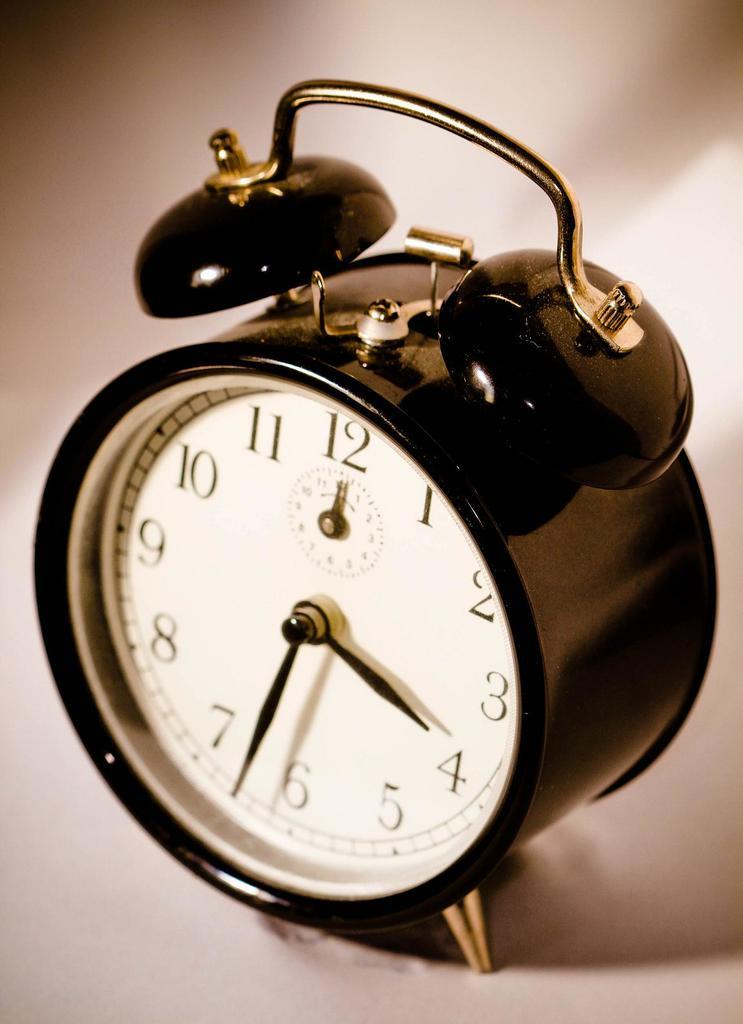What time does the alarm clock say?
Provide a succinct answer. 3:33. What does the big hand play?
Offer a terse response. 6. 